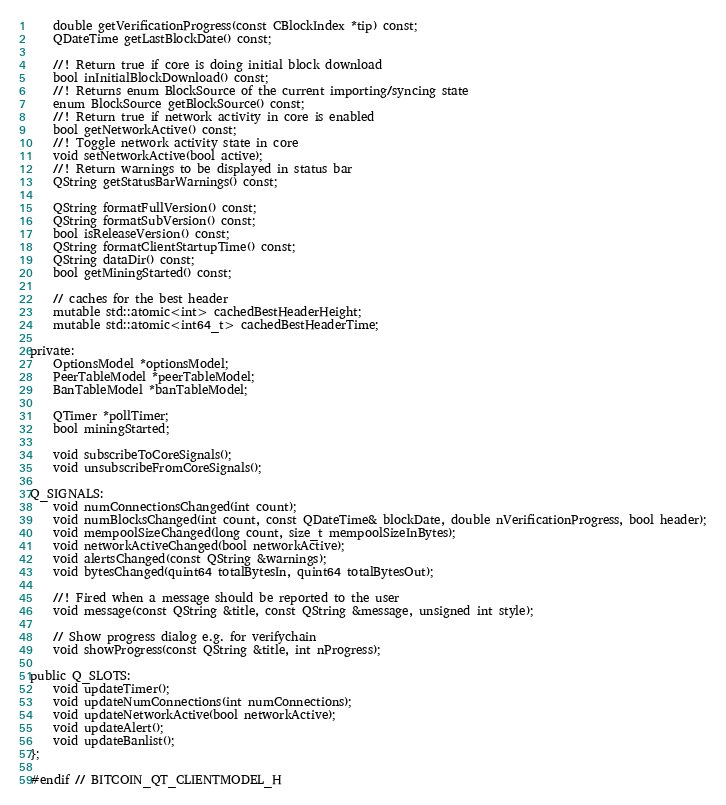<code> <loc_0><loc_0><loc_500><loc_500><_C_>    double getVerificationProgress(const CBlockIndex *tip) const;
    QDateTime getLastBlockDate() const;

    //! Return true if core is doing initial block download
    bool inInitialBlockDownload() const;
    //! Returns enum BlockSource of the current importing/syncing state
    enum BlockSource getBlockSource() const;
    //! Return true if network activity in core is enabled
    bool getNetworkActive() const;
    //! Toggle network activity state in core
    void setNetworkActive(bool active);
    //! Return warnings to be displayed in status bar
    QString getStatusBarWarnings() const;

    QString formatFullVersion() const;
    QString formatSubVersion() const;
    bool isReleaseVersion() const;
    QString formatClientStartupTime() const;
    QString dataDir() const;
    bool getMiningStarted() const;

    // caches for the best header
    mutable std::atomic<int> cachedBestHeaderHeight;
    mutable std::atomic<int64_t> cachedBestHeaderTime;

private:
    OptionsModel *optionsModel;
    PeerTableModel *peerTableModel;
    BanTableModel *banTableModel;

    QTimer *pollTimer;
    bool miningStarted;

    void subscribeToCoreSignals();
    void unsubscribeFromCoreSignals();

Q_SIGNALS:
    void numConnectionsChanged(int count);
    void numBlocksChanged(int count, const QDateTime& blockDate, double nVerificationProgress, bool header);
    void mempoolSizeChanged(long count, size_t mempoolSizeInBytes);
    void networkActiveChanged(bool networkActive);
    void alertsChanged(const QString &warnings);
    void bytesChanged(quint64 totalBytesIn, quint64 totalBytesOut);

    //! Fired when a message should be reported to the user
    void message(const QString &title, const QString &message, unsigned int style);

    // Show progress dialog e.g. for verifychain
    void showProgress(const QString &title, int nProgress);

public Q_SLOTS:
    void updateTimer();
    void updateNumConnections(int numConnections);
    void updateNetworkActive(bool networkActive);
    void updateAlert();
    void updateBanlist();
};

#endif // BITCOIN_QT_CLIENTMODEL_H
</code> 